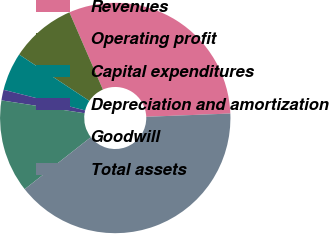Convert chart. <chart><loc_0><loc_0><loc_500><loc_500><pie_chart><fcel>Revenues<fcel>Operating profit<fcel>Capital expenditures<fcel>Depreciation and amortization<fcel>Goodwill<fcel>Total assets<nl><fcel>30.9%<fcel>9.2%<fcel>5.35%<fcel>1.49%<fcel>13.05%<fcel>40.02%<nl></chart> 